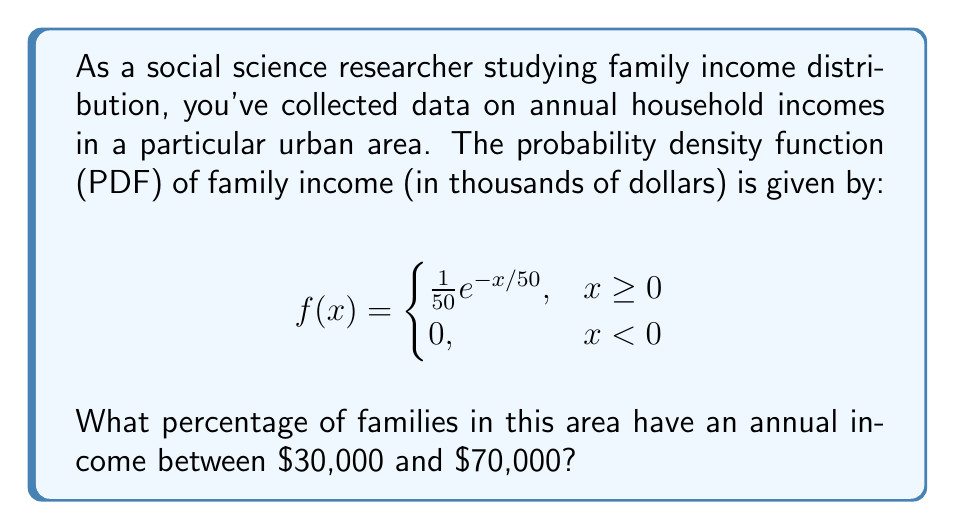Could you help me with this problem? To solve this problem, we need to integrate the probability density function between the given income limits. Here's the step-by-step solution:

1) We need to calculate $P(30 \leq X \leq 70)$, where $X$ represents the family income in thousands of dollars.

2) This probability is given by the integral:

   $$P(30 \leq X \leq 70) = \int_{30}^{70} f(x) dx$$

3) Substituting our PDF:

   $$P(30 \leq X \leq 70) = \int_{30}^{70} \frac{1}{50}e^{-x/50} dx$$

4) To solve this integral, we can use the substitution method. Let $u = -x/50$, then $du = -\frac{1}{50}dx$. When $x = 30$, $u = -3/5$, and when $x = 70$, $u = -7/5$.

5) Rewriting the integral:

   $$P(30 \leq X \leq 70) = \int_{-7/5}^{-3/5} -e^u du = [e^u]_{-7/5}^{-3/5}$$

6) Evaluating:

   $$P(30 \leq X \leq 70) = e^{-3/5} - e^{-7/5}$$

7) Calculate the numeric value:

   $$P(30 \leq X \leq 70) \approx 0.5488 - 0.2466 = 0.3022$$

8) Convert to percentage:

   $0.3022 \times 100\% = 30.22\%$

Therefore, approximately 30.22% of families in this area have an annual income between $30,000 and $70,000.
Answer: 30.22% 